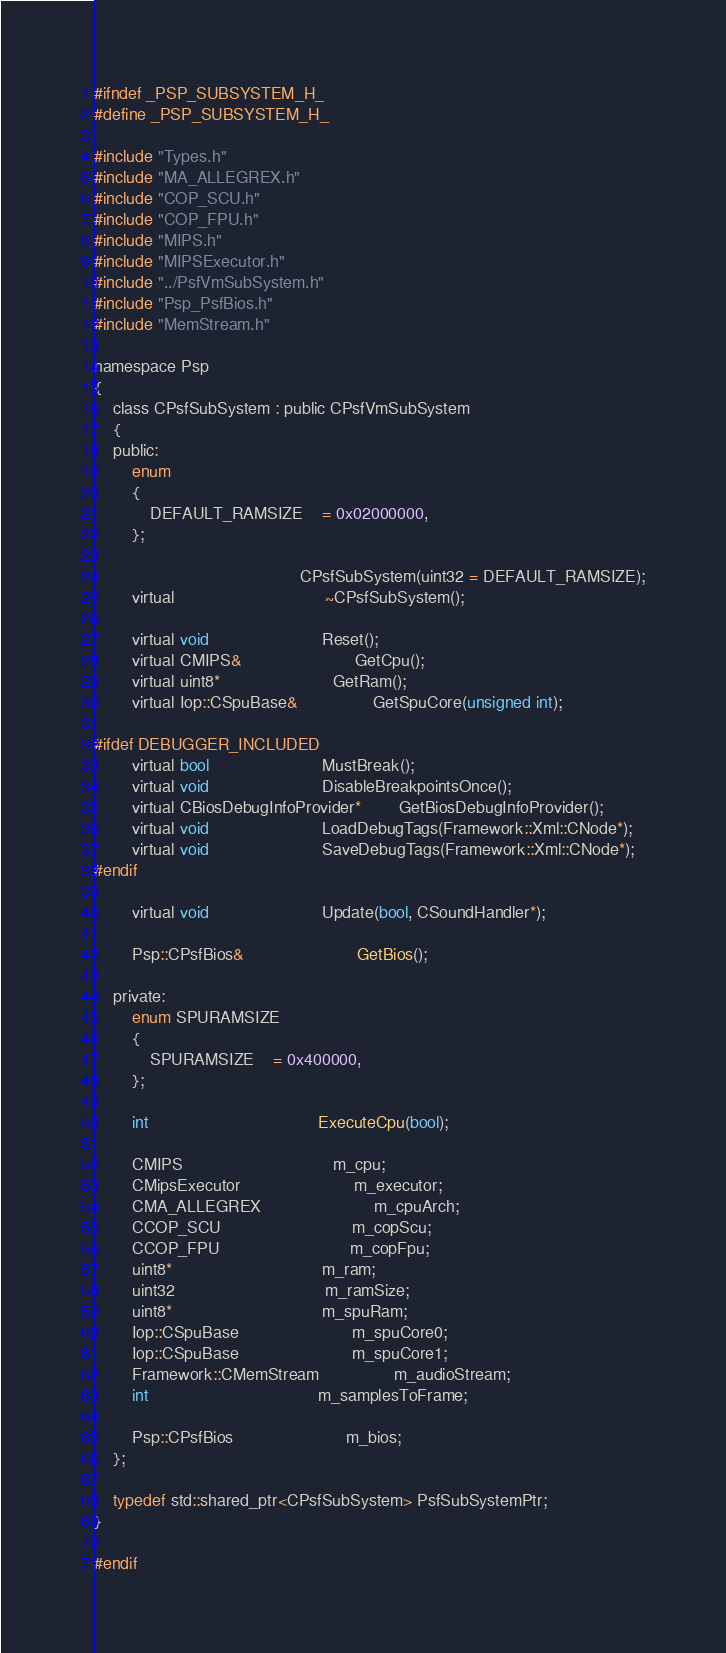Convert code to text. <code><loc_0><loc_0><loc_500><loc_500><_C_>#ifndef _PSP_SUBSYSTEM_H_
#define _PSP_SUBSYSTEM_H_

#include "Types.h"
#include "MA_ALLEGREX.h"
#include "COP_SCU.h"
#include "COP_FPU.h"
#include "MIPS.h"
#include "MIPSExecutor.h"
#include "../PsfVmSubSystem.h"
#include "Psp_PsfBios.h"
#include "MemStream.h"

namespace Psp
{
	class CPsfSubSystem : public CPsfVmSubSystem
	{
	public:
		enum
		{
			DEFAULT_RAMSIZE	= 0x02000000,
		};

											CPsfSubSystem(uint32 = DEFAULT_RAMSIZE);
		virtual								~CPsfSubSystem();

		virtual void						Reset();
		virtual CMIPS&						GetCpu();
		virtual uint8*						GetRam();
		virtual Iop::CSpuBase&				GetSpuCore(unsigned int);

#ifdef DEBUGGER_INCLUDED
		virtual bool						MustBreak();
		virtual void						DisableBreakpointsOnce();
		virtual CBiosDebugInfoProvider*		GetBiosDebugInfoProvider();
		virtual void						LoadDebugTags(Framework::Xml::CNode*);
		virtual void						SaveDebugTags(Framework::Xml::CNode*);
#endif

		virtual void						Update(bool, CSoundHandler*);

		Psp::CPsfBios&						GetBios();

	private:
		enum SPURAMSIZE
		{
			SPURAMSIZE	= 0x400000,
		};

		int									ExecuteCpu(bool);

		CMIPS								m_cpu;
		CMipsExecutor						m_executor;
		CMA_ALLEGREX						m_cpuArch;
		CCOP_SCU							m_copScu;
		CCOP_FPU							m_copFpu;
		uint8*								m_ram;
		uint32								m_ramSize;
		uint8*								m_spuRam;
		Iop::CSpuBase						m_spuCore0;
		Iop::CSpuBase						m_spuCore1;
		Framework::CMemStream				m_audioStream;
		int									m_samplesToFrame;

		Psp::CPsfBios						m_bios;
	};

	typedef std::shared_ptr<CPsfSubSystem> PsfSubSystemPtr;
}

#endif
</code> 